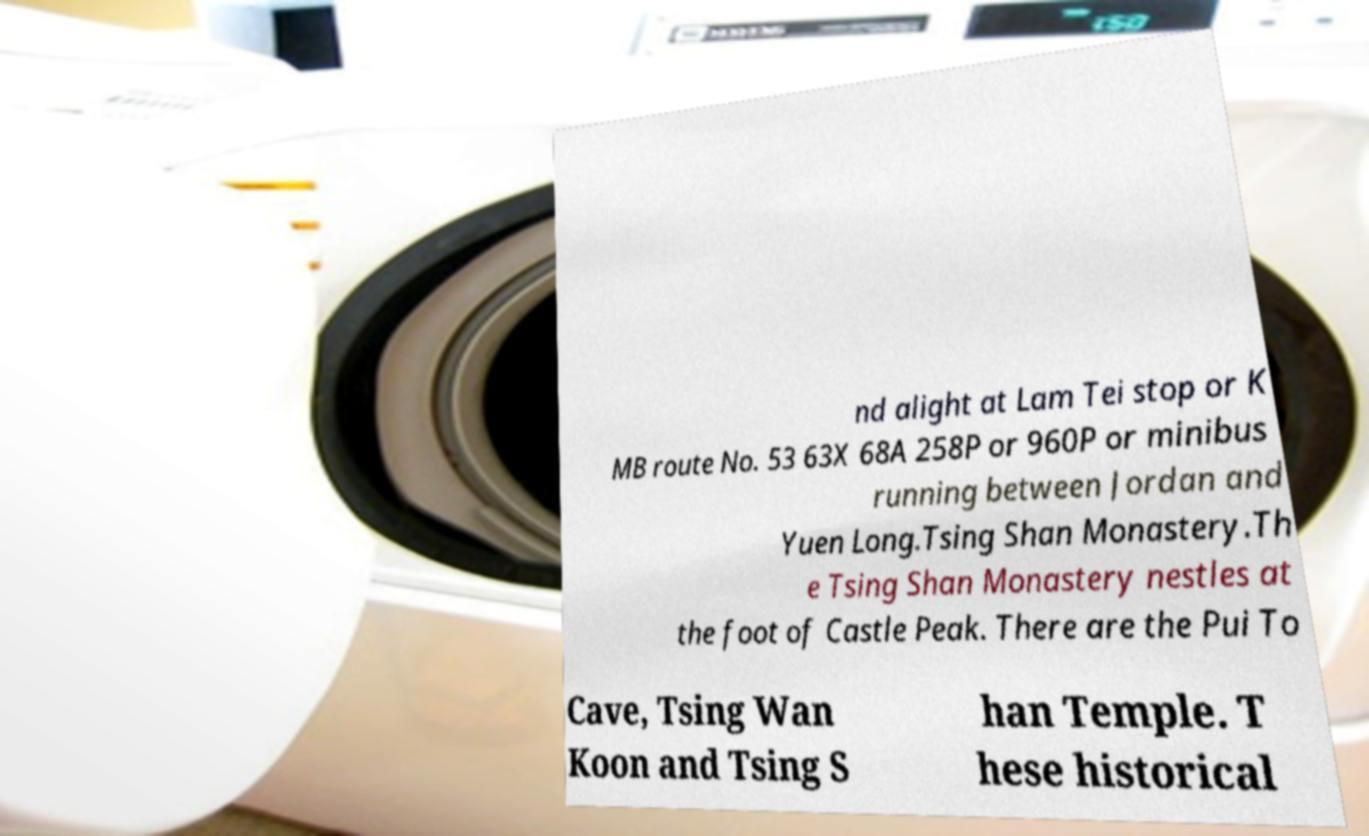Please identify and transcribe the text found in this image. nd alight at Lam Tei stop or K MB route No. 53 63X 68A 258P or 960P or minibus running between Jordan and Yuen Long.Tsing Shan Monastery.Th e Tsing Shan Monastery nestles at the foot of Castle Peak. There are the Pui To Cave, Tsing Wan Koon and Tsing S han Temple. T hese historical 